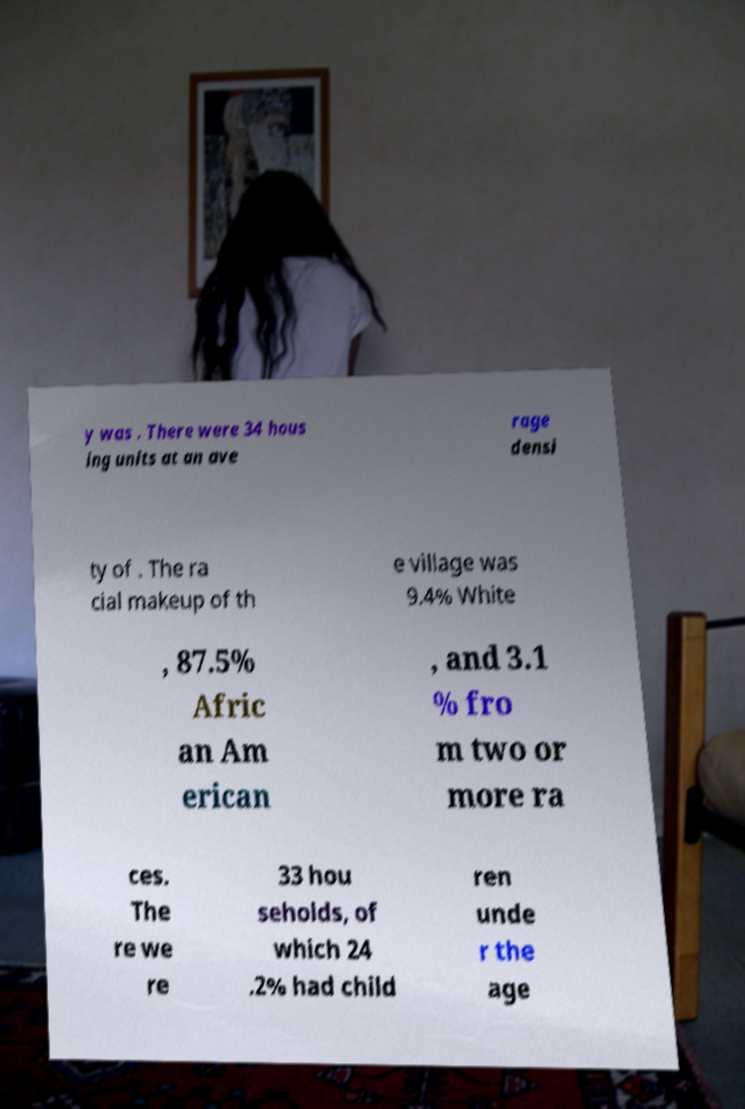What messages or text are displayed in this image? I need them in a readable, typed format. y was . There were 34 hous ing units at an ave rage densi ty of . The ra cial makeup of th e village was 9.4% White , 87.5% Afric an Am erican , and 3.1 % fro m two or more ra ces. The re we re 33 hou seholds, of which 24 .2% had child ren unde r the age 